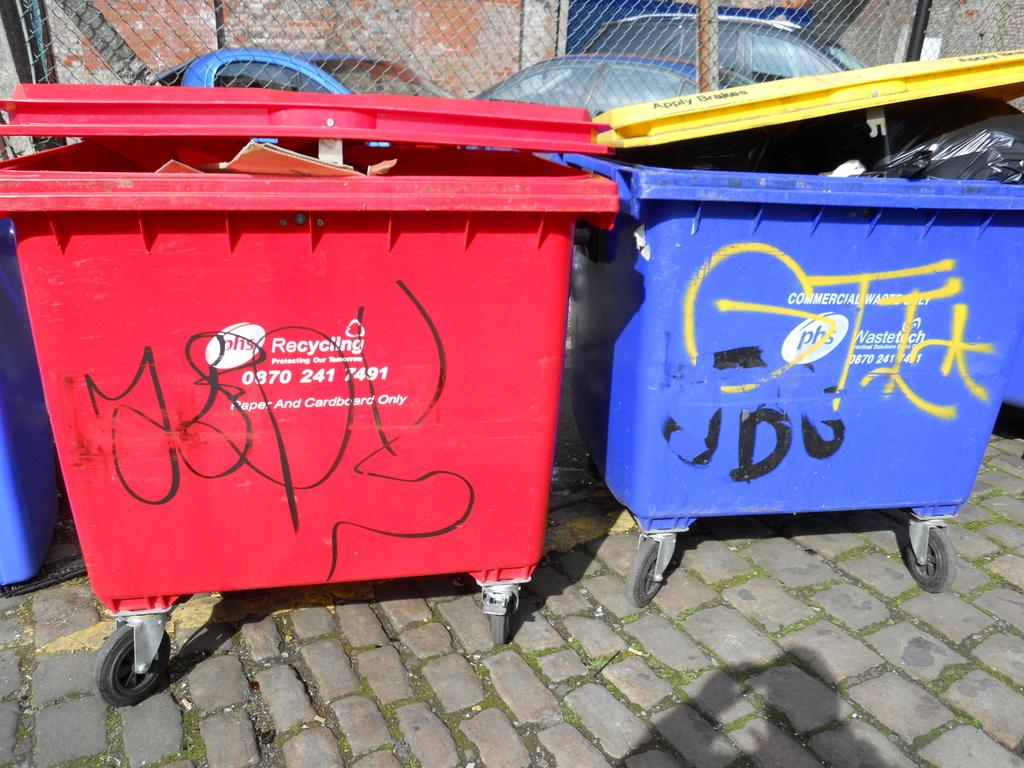<image>
Relay a brief, clear account of the picture shown. To garbage cans from PHS Recycling covered in grafitti 